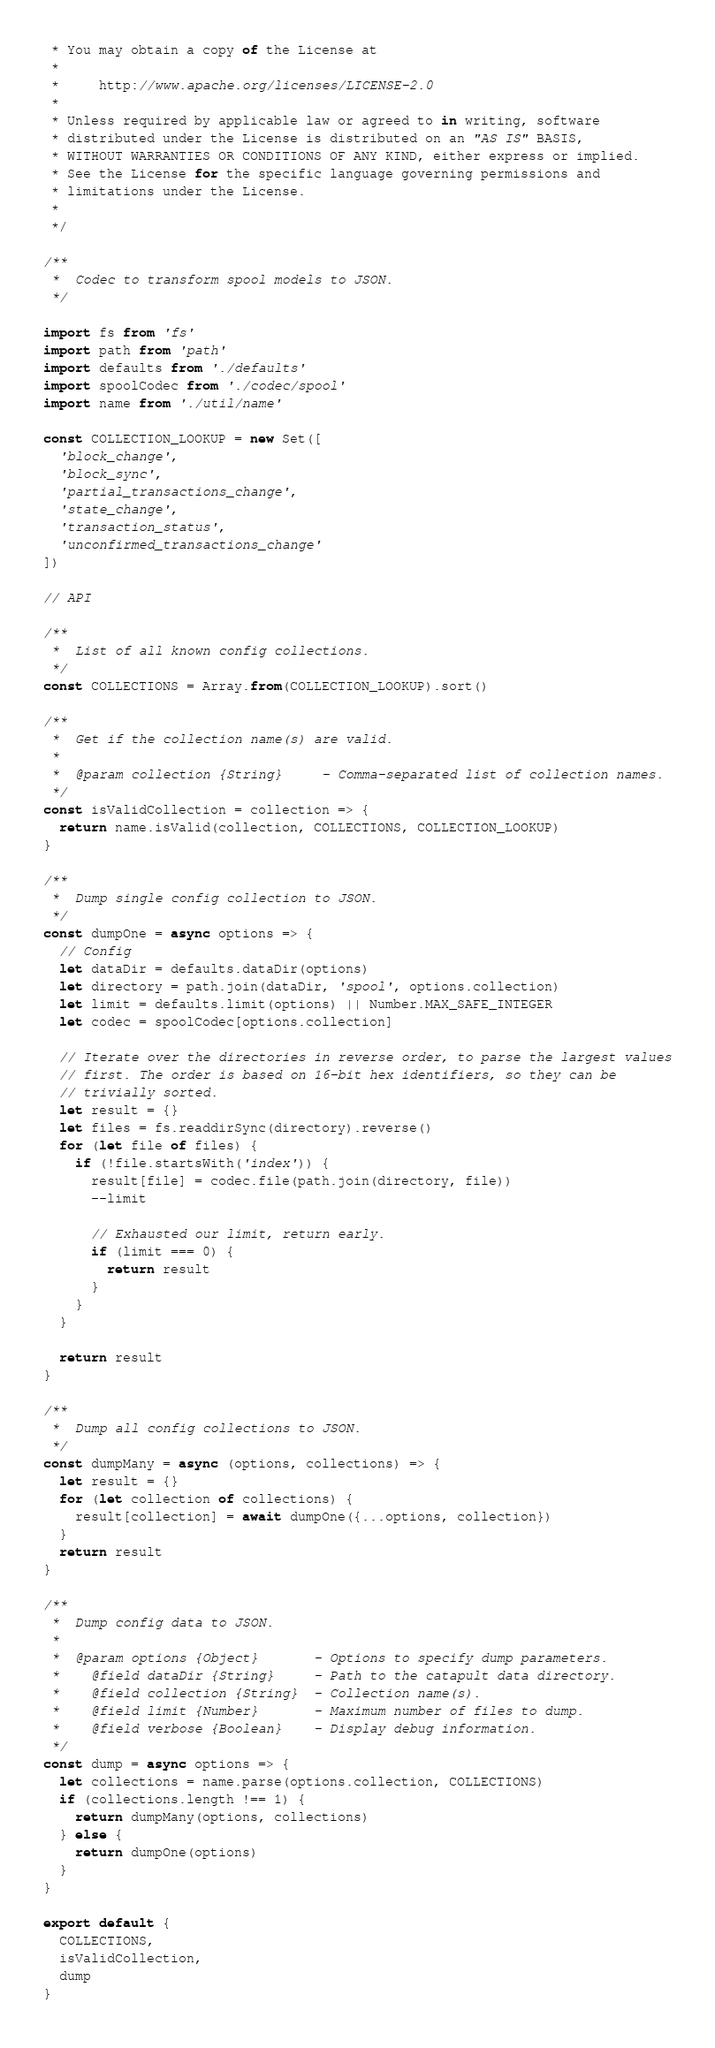<code> <loc_0><loc_0><loc_500><loc_500><_JavaScript_> * You may obtain a copy of the License at
 *
 *     http://www.apache.org/licenses/LICENSE-2.0
 *
 * Unless required by applicable law or agreed to in writing, software
 * distributed under the License is distributed on an "AS IS" BASIS,
 * WITHOUT WARRANTIES OR CONDITIONS OF ANY KIND, either express or implied.
 * See the License for the specific language governing permissions and
 * limitations under the License.
 *
 */

/**
 *  Codec to transform spool models to JSON.
 */

import fs from 'fs'
import path from 'path'
import defaults from './defaults'
import spoolCodec from './codec/spool'
import name from './util/name'

const COLLECTION_LOOKUP = new Set([
  'block_change',
  'block_sync',
  'partial_transactions_change',
  'state_change',
  'transaction_status',
  'unconfirmed_transactions_change'
])

// API

/**
 *  List of all known config collections.
 */
const COLLECTIONS = Array.from(COLLECTION_LOOKUP).sort()

/**
 *  Get if the collection name(s) are valid.
 *
 *  @param collection {String}     - Comma-separated list of collection names.
 */
const isValidCollection = collection => {
  return name.isValid(collection, COLLECTIONS, COLLECTION_LOOKUP)
}

/**
 *  Dump single config collection to JSON.
 */
const dumpOne = async options => {
  // Config
  let dataDir = defaults.dataDir(options)
  let directory = path.join(dataDir, 'spool', options.collection)
  let limit = defaults.limit(options) || Number.MAX_SAFE_INTEGER
  let codec = spoolCodec[options.collection]

  // Iterate over the directories in reverse order, to parse the largest values
  // first. The order is based on 16-bit hex identifiers, so they can be
  // trivially sorted.
  let result = {}
  let files = fs.readdirSync(directory).reverse()
  for (let file of files) {
    if (!file.startsWith('index')) {
      result[file] = codec.file(path.join(directory, file))
      --limit

      // Exhausted our limit, return early.
      if (limit === 0) {
        return result
      }
    }
  }

  return result
}

/**
 *  Dump all config collections to JSON.
 */
const dumpMany = async (options, collections) => {
  let result = {}
  for (let collection of collections) {
    result[collection] = await dumpOne({...options, collection})
  }
  return result
}

/**
 *  Dump config data to JSON.
 *
 *  @param options {Object}       - Options to specify dump parameters.
 *    @field dataDir {String}     - Path to the catapult data directory.
 *    @field collection {String}  - Collection name(s).
 *    @field limit {Number}       - Maximum number of files to dump.
 *    @field verbose {Boolean}    - Display debug information.
 */
const dump = async options => {
  let collections = name.parse(options.collection, COLLECTIONS)
  if (collections.length !== 1) {
    return dumpMany(options, collections)
  } else {
    return dumpOne(options)
  }
}

export default {
  COLLECTIONS,
  isValidCollection,
  dump
}
</code> 